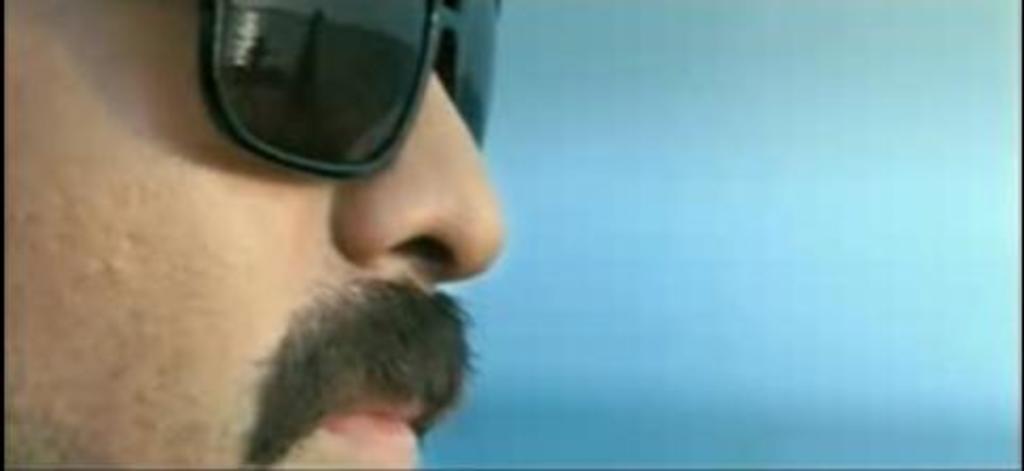Could you give a brief overview of what you see in this image? In this image we can see a face of a man. The man is having a mustache and a spectacles. 